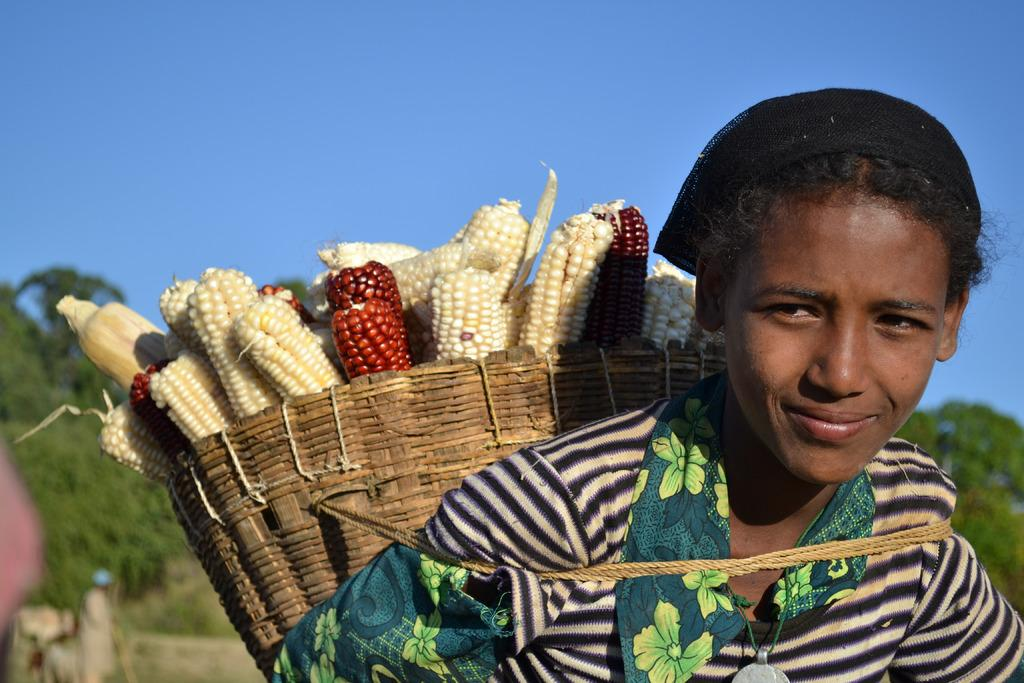Who is the main subject in the image? There is a girl in the image. What is the girl wearing in the image? The girl is wearing a basket. What is inside the basket that the girl is wearing? There are sweet corns inside the basket. What can be seen in the background of the image? There are trees and the sky visible in the background of the image. What finger is the girl using to reason with the lift in the image? There is no lift or finger-pointing activity present in the image. The girl is simply wearing a basket with sweet corns inside. 